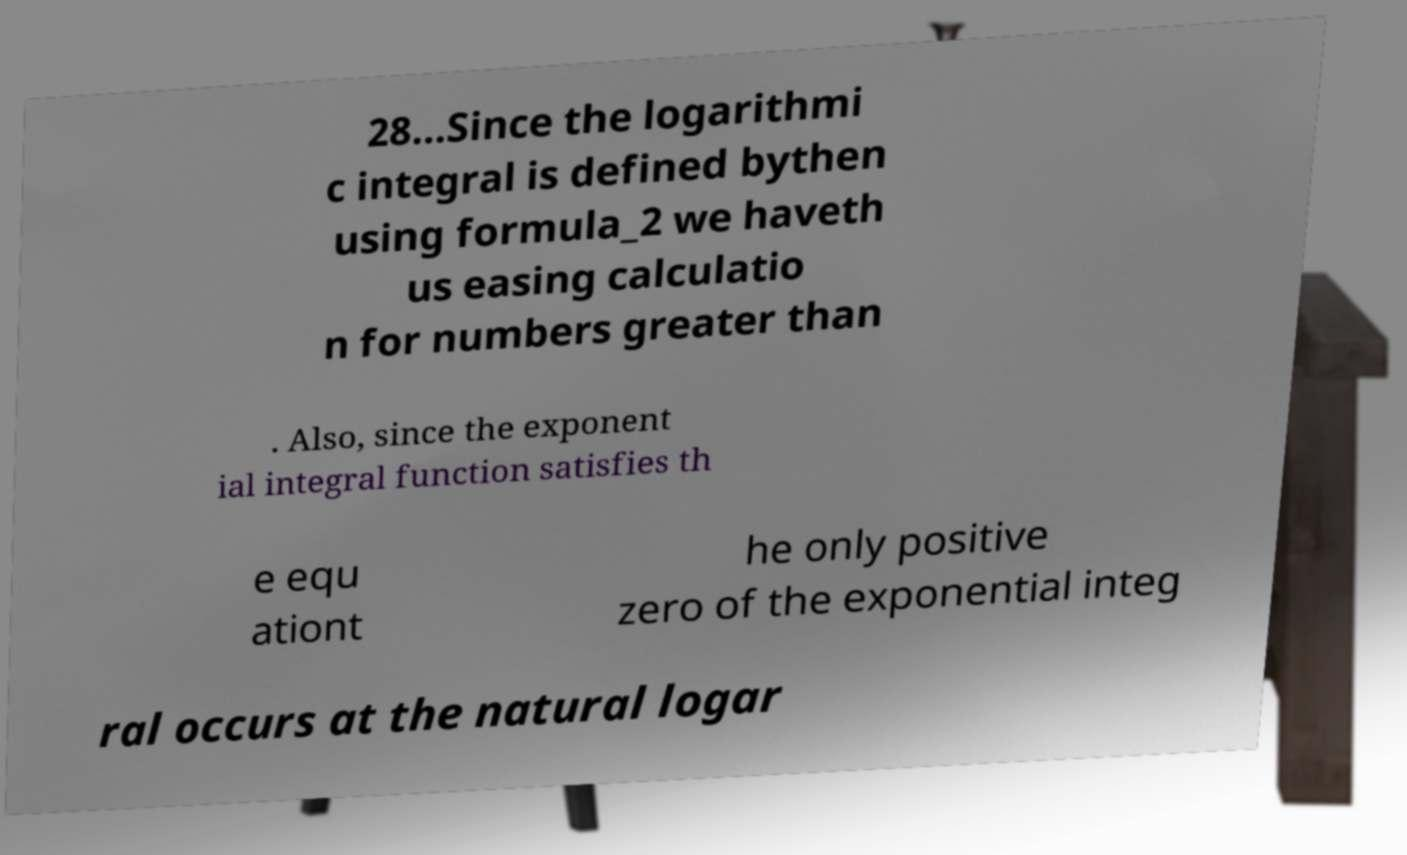Please read and relay the text visible in this image. What does it say? 28…Since the logarithmi c integral is defined bythen using formula_2 we haveth us easing calculatio n for numbers greater than . Also, since the exponent ial integral function satisfies th e equ ationt he only positive zero of the exponential integ ral occurs at the natural logar 